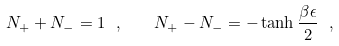<formula> <loc_0><loc_0><loc_500><loc_500>N _ { + } + N _ { - } = 1 \ , \quad N _ { + } - N _ { - } = - \tanh \frac { \beta \epsilon } { 2 } \ ,</formula> 